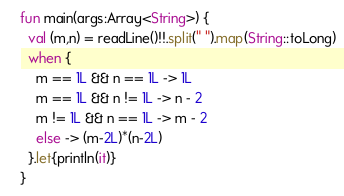<code> <loc_0><loc_0><loc_500><loc_500><_Kotlin_>fun main(args:Array<String>) {
  val (m,n) = readLine()!!.split(" ").map(String::toLong)
  when {
    m == 1L && n == 1L -> 1L
    m == 1L && n != 1L -> n - 2  
    m != 1L && n == 1L -> m - 2
    else -> (m-2L)*(n-2L)
  }.let{println(it)}
}

</code> 